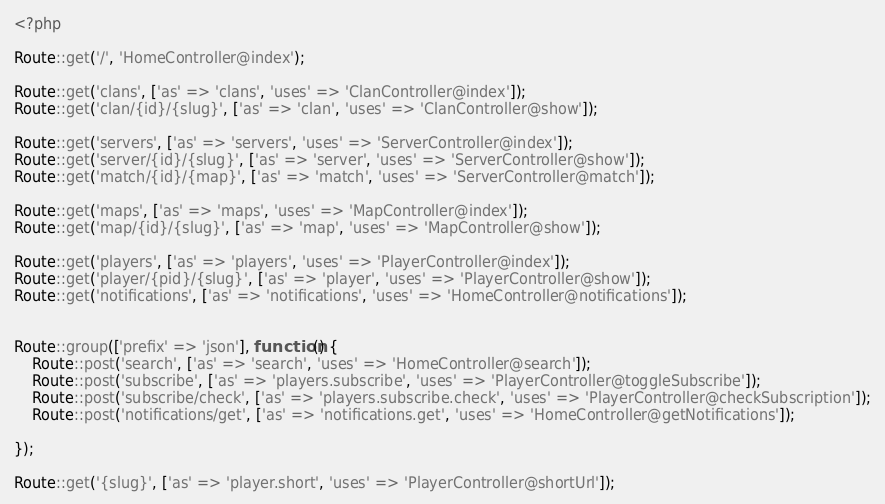Convert code to text. <code><loc_0><loc_0><loc_500><loc_500><_PHP_><?php

Route::get('/', 'HomeController@index');

Route::get('clans', ['as' => 'clans', 'uses' => 'ClanController@index']);
Route::get('clan/{id}/{slug}', ['as' => 'clan', 'uses' => 'ClanController@show']);

Route::get('servers', ['as' => 'servers', 'uses' => 'ServerController@index']);
Route::get('server/{id}/{slug}', ['as' => 'server', 'uses' => 'ServerController@show']);
Route::get('match/{id}/{map}', ['as' => 'match', 'uses' => 'ServerController@match']);

Route::get('maps', ['as' => 'maps', 'uses' => 'MapController@index']);
Route::get('map/{id}/{slug}', ['as' => 'map', 'uses' => 'MapController@show']);

Route::get('players', ['as' => 'players', 'uses' => 'PlayerController@index']);
Route::get('player/{pid}/{slug}', ['as' => 'player', 'uses' => 'PlayerController@show']);
Route::get('notifications', ['as' => 'notifications', 'uses' => 'HomeController@notifications']);


Route::group(['prefix' => 'json'], function() {
    Route::post('search', ['as' => 'search', 'uses' => 'HomeController@search']);
    Route::post('subscribe', ['as' => 'players.subscribe', 'uses' => 'PlayerController@toggleSubscribe']);
    Route::post('subscribe/check', ['as' => 'players.subscribe.check', 'uses' => 'PlayerController@checkSubscription']);
    Route::post('notifications/get', ['as' => 'notifications.get', 'uses' => 'HomeController@getNotifications']);

});

Route::get('{slug}', ['as' => 'player.short', 'uses' => 'PlayerController@shortUrl']);
</code> 